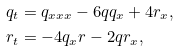<formula> <loc_0><loc_0><loc_500><loc_500>& q _ { t } = q _ { x x x } - 6 q q _ { x } + 4 r _ { x } , \\ & r _ { t } = - 4 q _ { x } r - 2 q r _ { x } ,</formula> 